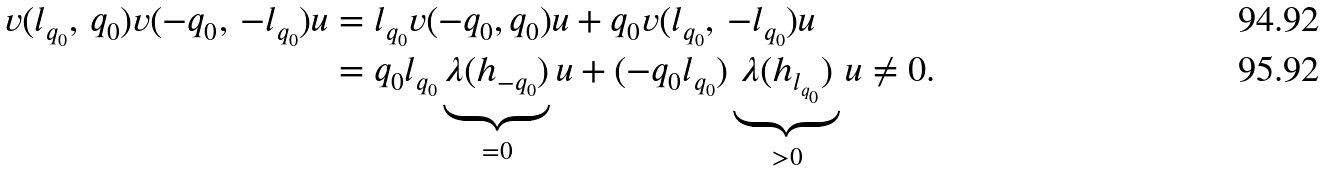<formula> <loc_0><loc_0><loc_500><loc_500>v ( l _ { q _ { 0 } } , \, q _ { 0 } ) v ( - q _ { 0 } , \, - l _ { q _ { 0 } } ) u & = l _ { q _ { 0 } } v ( - q _ { 0 } , q _ { 0 } ) u + q _ { 0 } v ( l _ { q _ { 0 } } , \, - l _ { q _ { 0 } } ) u \\ & = q _ { 0 } l _ { q _ { 0 } } \underbrace { \lambda ( h _ { - q _ { 0 } } ) } _ { = 0 } u + ( - q _ { 0 } l _ { q _ { 0 } } ) \underbrace { \lambda ( h _ { l _ { q _ { 0 } } } ) } _ { > 0 } u \ne 0 .</formula> 